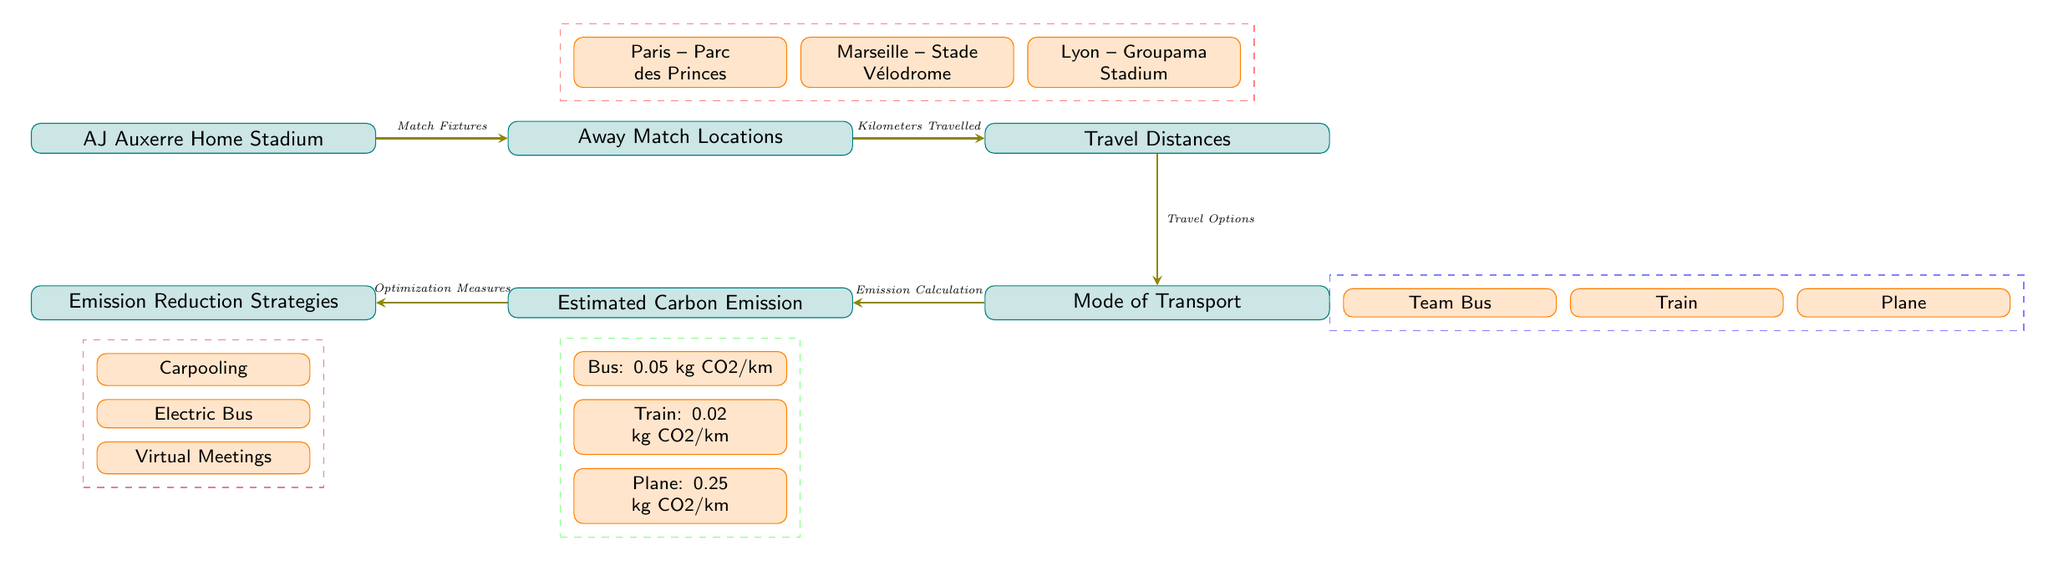What are the main away match locations for AJ Auxerre? The diagram lists three specific away match locations for AJ Auxerre, which are Paris (Parc des Princes), Marseille (Stade Vélodrome), and Lyon (Groupama Stadium).
Answer: Paris – Parc des Princes, Marseille – Stade Vélodrome, Lyon – Groupama Stadium What transportation options are available for away matches? The diagram indicates three modes of transport available for AJ Auxerre's away matches: Team Bus, Train, and Plane.
Answer: Team Bus, Train, Plane Which mode of transport has the lowest carbon emission per kilometer? The diagram shows the estimated carbon emissions for different transport modes. The Train has the lowest emission at 0.02 kg CO2/km.
Answer: Train: 0.02 kg CO2/km What is the carbon emissions for the bus travel option? The diagram specifies that the carbon emissions for the bus travel option is 0.05 kg CO2/km.
Answer: Bus: 0.05 kg CO2/km How many emission reduction strategies are suggested? The diagram lists three emission reduction strategies: Carpooling, Electric Bus, and Virtual Meetings, indicating a total of three strategies.
Answer: 3 What type of node connects the Team Bus to Estimated Carbon Emission? The Team Bus node is connected to the Estimated Carbon Emission node through the Mode of Transport node, which describes the function of transportation options leading to emissions calculated.
Answer: Mode of Transport What do the dashed red lines surround? The dashed red lines encompass the main away match locations for AJ Auxerre, which include Paris, Marseille, and Lyon.
Answer: Paris, Marseille, Lyon What is the estimated carbon emission for plane travel? According to the diagram, the estimated carbon emission for plane travel is stated as 0.25 kg CO2/km.
Answer: Plane: 0.25 kg CO2/km What concept links Emission Reduction Strategies to Estimated Carbon Emission? The link is established via Optimization Measures, which implies that there are measures taken to reduce emissions calculated in the preceding steps.
Answer: Optimization Measures 